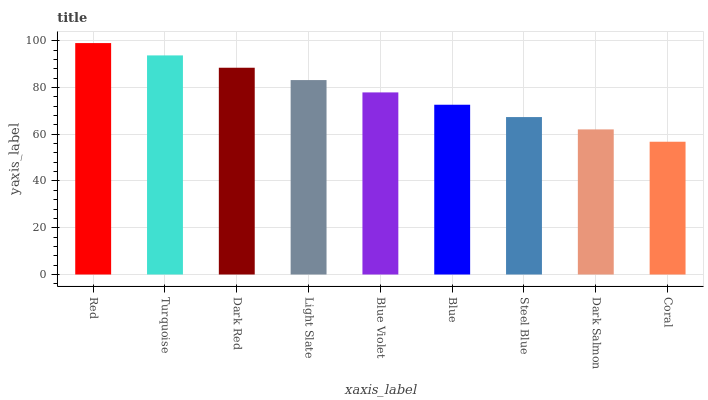Is Coral the minimum?
Answer yes or no. Yes. Is Red the maximum?
Answer yes or no. Yes. Is Turquoise the minimum?
Answer yes or no. No. Is Turquoise the maximum?
Answer yes or no. No. Is Red greater than Turquoise?
Answer yes or no. Yes. Is Turquoise less than Red?
Answer yes or no. Yes. Is Turquoise greater than Red?
Answer yes or no. No. Is Red less than Turquoise?
Answer yes or no. No. Is Blue Violet the high median?
Answer yes or no. Yes. Is Blue Violet the low median?
Answer yes or no. Yes. Is Coral the high median?
Answer yes or no. No. Is Blue the low median?
Answer yes or no. No. 